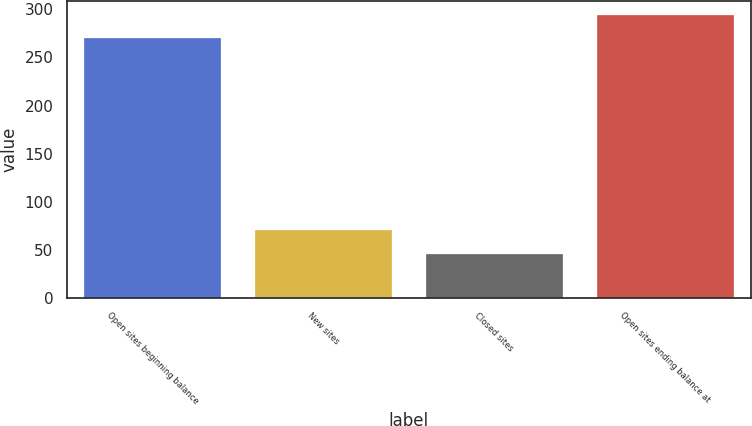<chart> <loc_0><loc_0><loc_500><loc_500><bar_chart><fcel>Open sites beginning balance<fcel>New sites<fcel>Closed sites<fcel>Open sites ending balance at<nl><fcel>270<fcel>70.4<fcel>46<fcel>294.4<nl></chart> 